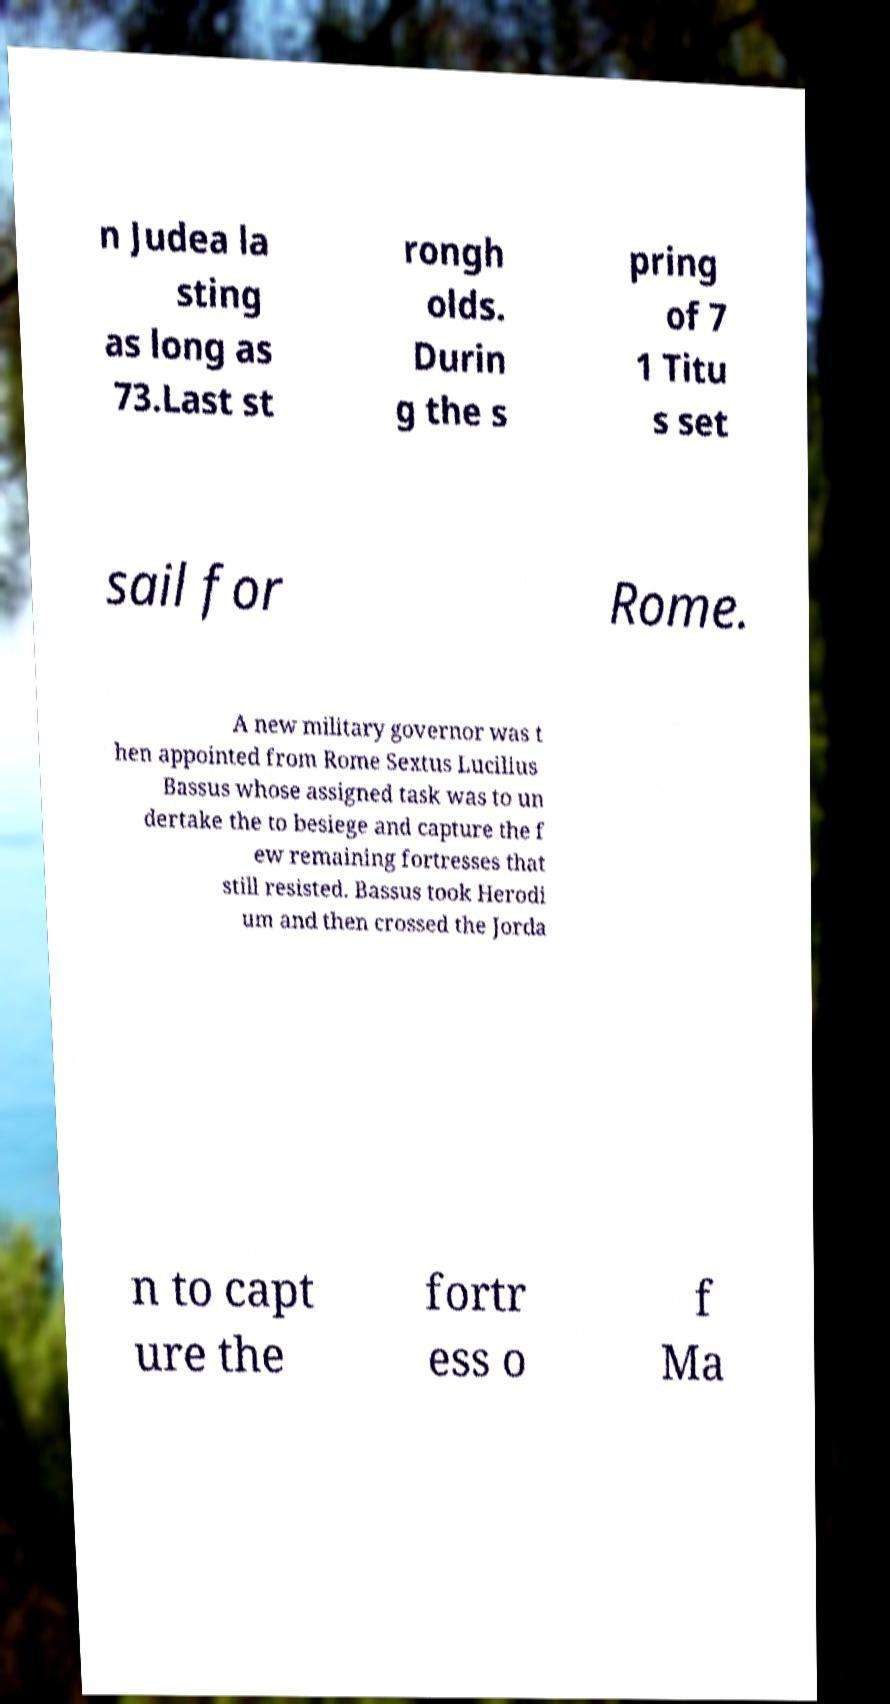What messages or text are displayed in this image? I need them in a readable, typed format. n Judea la sting as long as 73.Last st rongh olds. Durin g the s pring of 7 1 Titu s set sail for Rome. A new military governor was t hen appointed from Rome Sextus Lucilius Bassus whose assigned task was to un dertake the to besiege and capture the f ew remaining fortresses that still resisted. Bassus took Herodi um and then crossed the Jorda n to capt ure the fortr ess o f Ma 